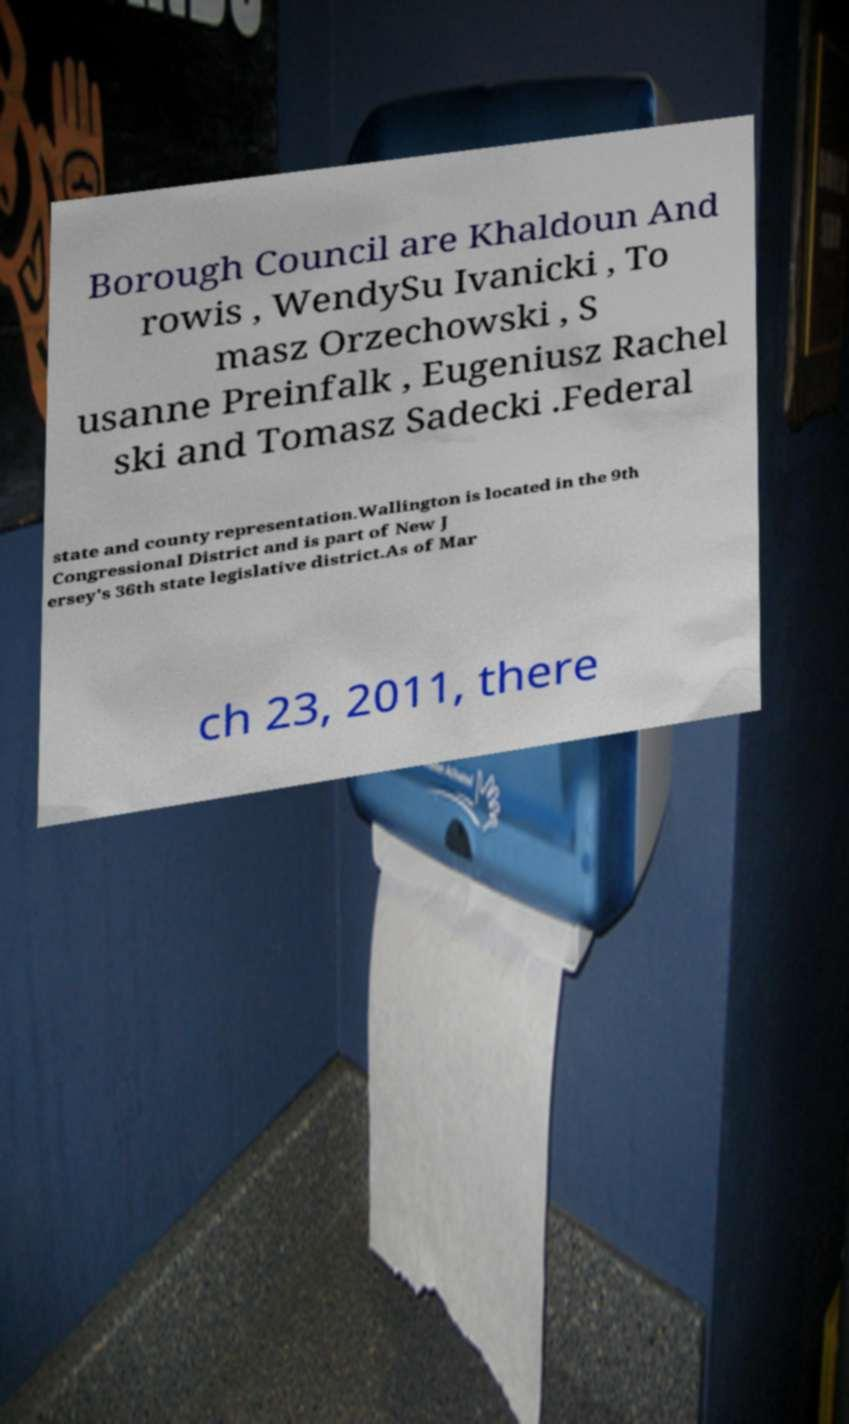I need the written content from this picture converted into text. Can you do that? Borough Council are Khaldoun And rowis , WendySu Ivanicki , To masz Orzechowski , S usanne Preinfalk , Eugeniusz Rachel ski and Tomasz Sadecki .Federal state and county representation.Wallington is located in the 9th Congressional District and is part of New J ersey's 36th state legislative district.As of Mar ch 23, 2011, there 